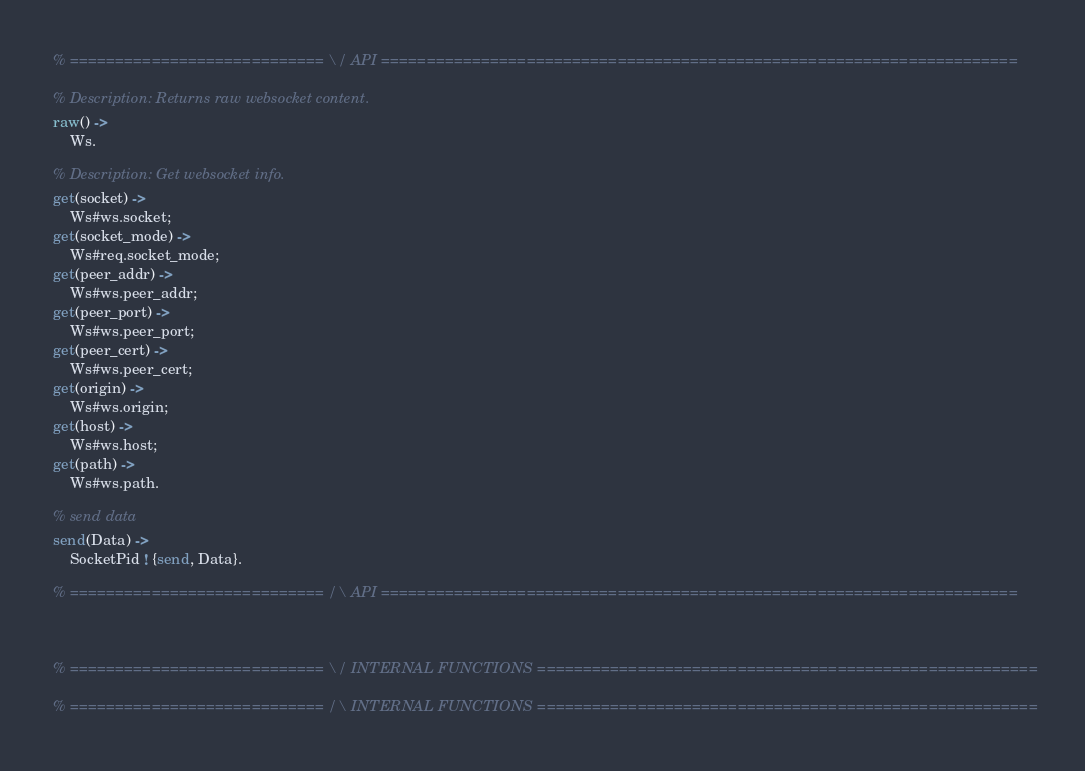<code> <loc_0><loc_0><loc_500><loc_500><_Erlang_>
% ============================ \/ API ======================================================================

% Description: Returns raw websocket content.
raw() ->
	Ws.

% Description: Get websocket info.
get(socket) ->
	Ws#ws.socket;
get(socket_mode) ->
	Ws#req.socket_mode;
get(peer_addr) ->
	Ws#ws.peer_addr;
get(peer_port) ->
	Ws#ws.peer_port;
get(peer_cert) ->
	Ws#ws.peer_cert;
get(origin) ->
	Ws#ws.origin;
get(host) ->
	Ws#ws.host;
get(path) ->
	Ws#ws.path.
	
% send data
send(Data) ->
	SocketPid ! {send, Data}.
		
% ============================ /\ API ======================================================================



% ============================ \/ INTERNAL FUNCTIONS =======================================================

% ============================ /\ INTERNAL FUNCTIONS =======================================================
</code> 